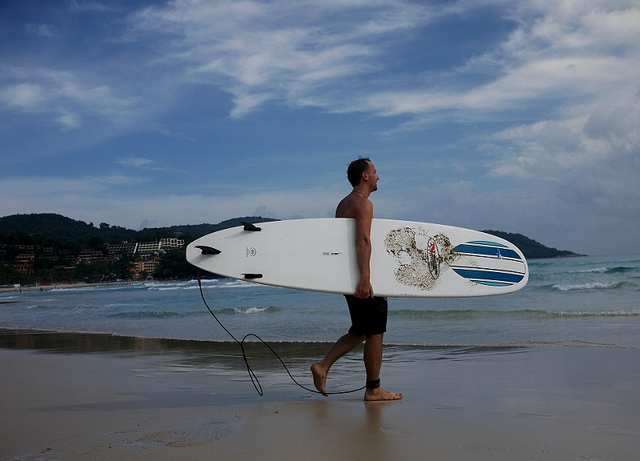<image>What object is painted on the surfboard? It is unclear what object is painted on the surfboard. It could be anything from a circle, art, oval, mickey mouse, bird, hawk, strips, or fins. What object is painted on the surfboard? I don't know what object is painted on the surfboard. It can be seen as a circle, art, oval, mickey mouse, bird, hawk, strips, or fins. 